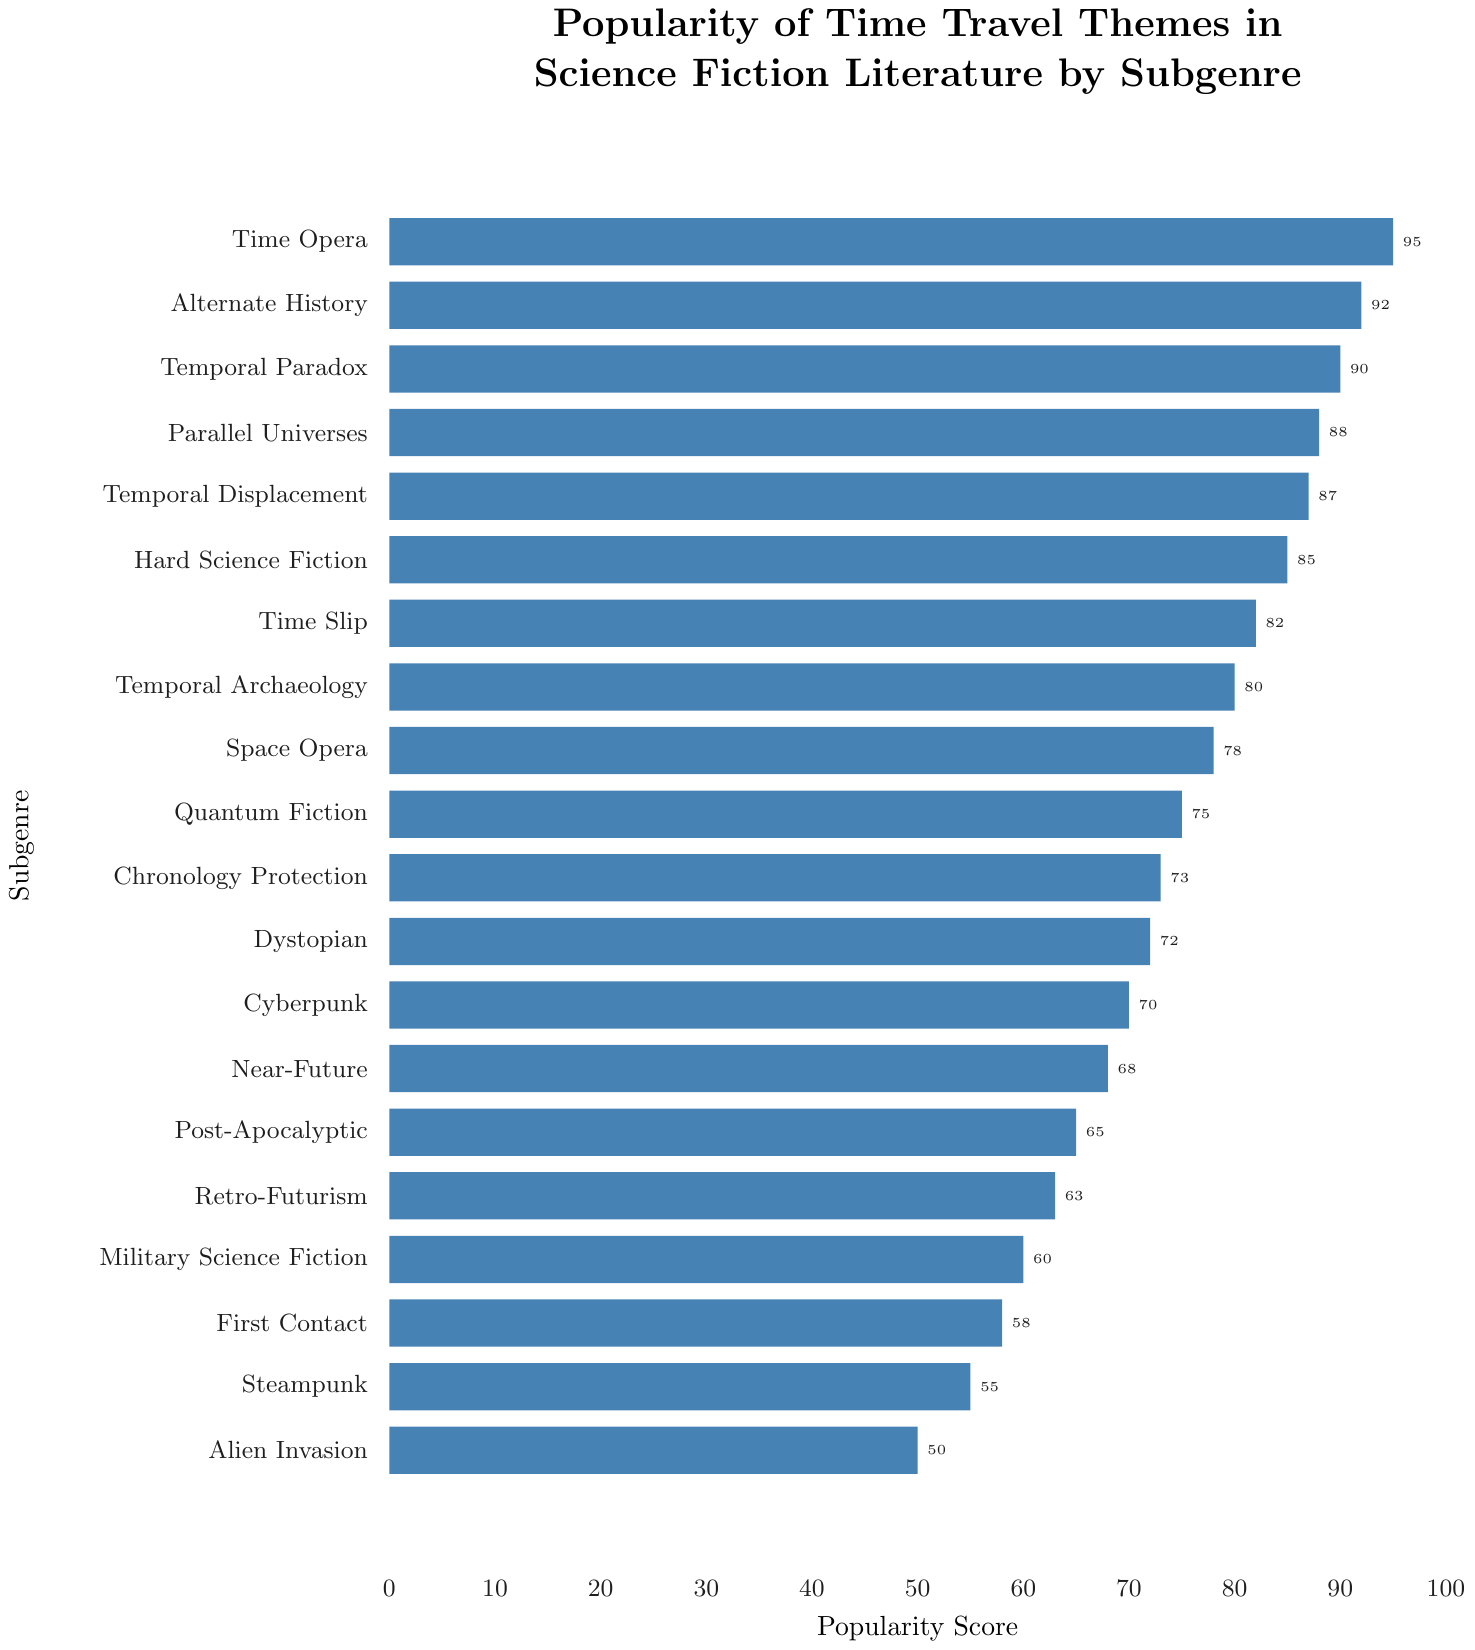Which subgenre has the highest popularity score? Identify the tallest bar in the chart, which represents the highest popularity score. The subgenre with the tallest bar is Time Opera, with a score of 95.
Answer: Time Opera Which subgenre has the lowest popularity score? Look for the shortest bar in the chart, representing the lowest popularity score. The shortest bar corresponds to Alien Invasion, with a score of 50.
Answer: Alien Invasion What is the difference in popularity score between Space Opera and Cyberpunk? Find the bars for Space Opera and Cyberpunk. Space Opera has a score of 78, and Cyberpunk has a score of 70. The difference is calculated as 78 - 70.
Answer: 8 Which subgenre has a higher popularity score, Hard Science Fiction or Temporal Displacement? Identify the bars for Hard Science Fiction and Temporal Displacement. Hard Science Fiction has a score of 85, while Temporal Displacement has a score of 87. Since 87 > 85, Temporal Displacement has a higher score.
Answer: Temporal Displacement What is the average popularity score of the following subgenres: Dystopian, Near-Future, and Retro-Futurism? Find the bars for Dystopian, Near-Future, and Retro-Futurism. The scores are 72, 68, and 63, respectively. Calculate the average as (72 + 68 + 63) / 3.
Answer: 67.67 How many subgenres have a popularity score higher than 80? Count the number of bars with a score greater than 80. These subgenres are Time Opera (95), Alternate History (92), Temporal Paradox (90), Parallel Universes (88), Temporal Displacement (87), Hard Science Fiction (85), and Time Slip (82). There are 7 subgenres in total.
Answer: 7 In terms of popularity score, how much more popular is Time Slip compared to First Contact? Find the bars for Time Slip and First Contact. Time Slip has a score of 82, and First Contact has a score of 58. The difference is 82 - 58.
Answer: 24 What is the median popularity score among all subgenres? List the popularity scores in ascending order: 50, 55, 58, 60, 63, 65, 68, 70, 72, 73, 75, 78, 80, 82, 85, 87, 88, 90, 92, 95. The median score is the middle value when the data set is ordered. For 20 data points, it is the average of the 10th and 11th scores: (72 + 73) / 2.
Answer: 72.5 Are there more subgenres with scores above or below 70? Count the number of subgenres with scores above 70 and those below 70. Subgenres above 70: 12 (Time Opera, Alternate History, Temporal Paradox, Parallel Universes, Temporal Displacement, Hard Science Fiction, Time Slip, Temporal Archaeology, Dystopian, Space Opera, Quantum Fiction, Chronology Protection). Subgenres below 70: 8 (Cyberpunk, Near-Future, Post-Apocalyptic, Retro-Futurism, Military Science Fiction, First Contact, Steampunk, Alien Invasion). There are more above 70.
Answer: Above 70 Which subgenre has a closer popularity score to 75, Quantum Fiction or Space Opera? Find the bars for Quantum Fiction and Space Opera. Quantum Fiction has a score of 75, and Space Opera has a score of 78. The closer score to 75 is Quantum Fiction (exact match).
Answer: Quantum Fiction 